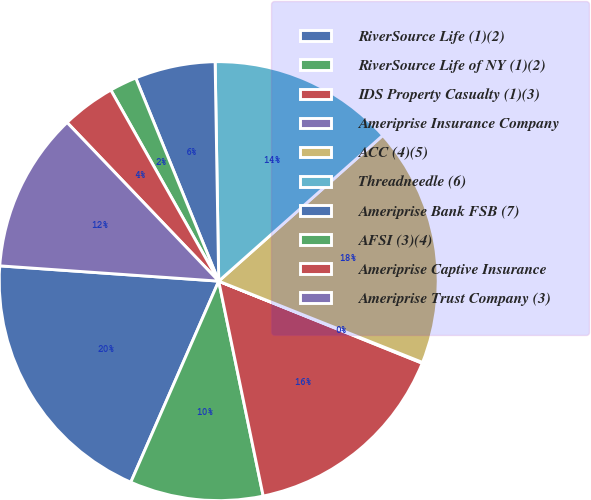<chart> <loc_0><loc_0><loc_500><loc_500><pie_chart><fcel>RiverSource Life (1)(2)<fcel>RiverSource Life of NY (1)(2)<fcel>IDS Property Casualty (1)(3)<fcel>Ameriprise Insurance Company<fcel>ACC (4)(5)<fcel>Threadneedle (6)<fcel>Ameriprise Bank FSB (7)<fcel>AFSI (3)(4)<fcel>Ameriprise Captive Insurance<fcel>Ameriprise Trust Company (3)<nl><fcel>19.55%<fcel>9.81%<fcel>15.65%<fcel>0.06%<fcel>17.6%<fcel>13.7%<fcel>5.91%<fcel>2.01%<fcel>3.96%<fcel>11.75%<nl></chart> 